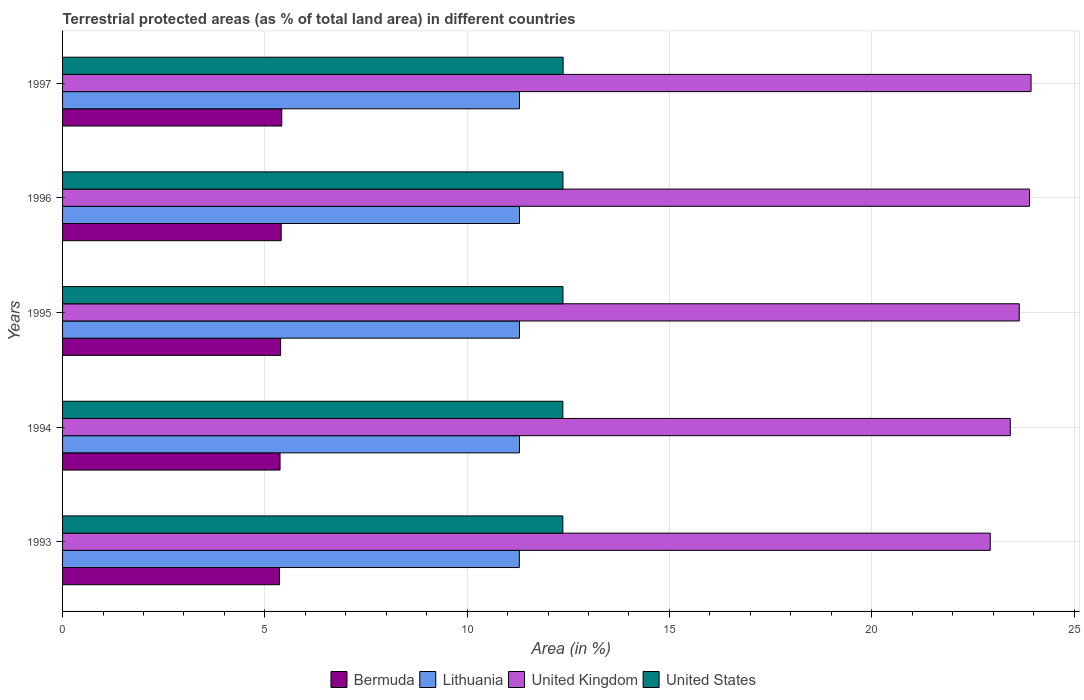Are the number of bars per tick equal to the number of legend labels?
Your answer should be compact. Yes. Are the number of bars on each tick of the Y-axis equal?
Your answer should be very brief. Yes. How many bars are there on the 2nd tick from the bottom?
Offer a very short reply. 4. What is the label of the 4th group of bars from the top?
Provide a short and direct response. 1994. In how many cases, is the number of bars for a given year not equal to the number of legend labels?
Your answer should be compact. 0. What is the percentage of terrestrial protected land in Bermuda in 1996?
Ensure brevity in your answer.  5.4. Across all years, what is the maximum percentage of terrestrial protected land in United States?
Make the answer very short. 12.37. Across all years, what is the minimum percentage of terrestrial protected land in United Kingdom?
Provide a succinct answer. 22.93. What is the total percentage of terrestrial protected land in Lithuania in the graph?
Your response must be concise. 56.47. What is the difference between the percentage of terrestrial protected land in Bermuda in 1994 and that in 1996?
Provide a short and direct response. -0.03. What is the difference between the percentage of terrestrial protected land in Lithuania in 1996 and the percentage of terrestrial protected land in Bermuda in 1997?
Your response must be concise. 5.88. What is the average percentage of terrestrial protected land in Lithuania per year?
Keep it short and to the point. 11.29. In the year 1993, what is the difference between the percentage of terrestrial protected land in Lithuania and percentage of terrestrial protected land in Bermuda?
Your answer should be very brief. 5.93. In how many years, is the percentage of terrestrial protected land in Bermuda greater than 11 %?
Make the answer very short. 0. What is the ratio of the percentage of terrestrial protected land in United States in 1993 to that in 1997?
Offer a terse response. 1. What is the difference between the highest and the second highest percentage of terrestrial protected land in United Kingdom?
Your answer should be compact. 0.04. What is the difference between the highest and the lowest percentage of terrestrial protected land in United Kingdom?
Your response must be concise. 1.01. Is it the case that in every year, the sum of the percentage of terrestrial protected land in Lithuania and percentage of terrestrial protected land in United States is greater than the sum of percentage of terrestrial protected land in Bermuda and percentage of terrestrial protected land in United Kingdom?
Your answer should be compact. Yes. What does the 3rd bar from the top in 1995 represents?
Keep it short and to the point. Lithuania. What does the 1st bar from the bottom in 1994 represents?
Your answer should be very brief. Bermuda. Is it the case that in every year, the sum of the percentage of terrestrial protected land in United States and percentage of terrestrial protected land in Bermuda is greater than the percentage of terrestrial protected land in Lithuania?
Your answer should be compact. Yes. What is the difference between two consecutive major ticks on the X-axis?
Offer a terse response. 5. Are the values on the major ticks of X-axis written in scientific E-notation?
Offer a very short reply. No. Does the graph contain any zero values?
Offer a terse response. No. Does the graph contain grids?
Provide a succinct answer. Yes. Where does the legend appear in the graph?
Offer a terse response. Bottom center. How many legend labels are there?
Give a very brief answer. 4. How are the legend labels stacked?
Your answer should be compact. Horizontal. What is the title of the graph?
Give a very brief answer. Terrestrial protected areas (as % of total land area) in different countries. What is the label or title of the X-axis?
Your answer should be compact. Area (in %). What is the label or title of the Y-axis?
Provide a succinct answer. Years. What is the Area (in %) of Bermuda in 1993?
Give a very brief answer. 5.36. What is the Area (in %) in Lithuania in 1993?
Keep it short and to the point. 11.29. What is the Area (in %) of United Kingdom in 1993?
Give a very brief answer. 22.93. What is the Area (in %) in United States in 1993?
Provide a succinct answer. 12.37. What is the Area (in %) of Bermuda in 1994?
Offer a terse response. 5.38. What is the Area (in %) of Lithuania in 1994?
Your response must be concise. 11.29. What is the Area (in %) of United Kingdom in 1994?
Your answer should be compact. 23.43. What is the Area (in %) of United States in 1994?
Offer a terse response. 12.37. What is the Area (in %) in Bermuda in 1995?
Provide a succinct answer. 5.39. What is the Area (in %) in Lithuania in 1995?
Offer a very short reply. 11.29. What is the Area (in %) in United Kingdom in 1995?
Make the answer very short. 23.65. What is the Area (in %) of United States in 1995?
Keep it short and to the point. 12.37. What is the Area (in %) of Bermuda in 1996?
Make the answer very short. 5.4. What is the Area (in %) of Lithuania in 1996?
Your answer should be very brief. 11.29. What is the Area (in %) of United Kingdom in 1996?
Your answer should be very brief. 23.9. What is the Area (in %) of United States in 1996?
Make the answer very short. 12.37. What is the Area (in %) in Bermuda in 1997?
Provide a succinct answer. 5.42. What is the Area (in %) of Lithuania in 1997?
Your response must be concise. 11.29. What is the Area (in %) of United Kingdom in 1997?
Keep it short and to the point. 23.94. What is the Area (in %) of United States in 1997?
Your response must be concise. 12.37. Across all years, what is the maximum Area (in %) of Bermuda?
Offer a terse response. 5.42. Across all years, what is the maximum Area (in %) of Lithuania?
Provide a short and direct response. 11.29. Across all years, what is the maximum Area (in %) of United Kingdom?
Your answer should be compact. 23.94. Across all years, what is the maximum Area (in %) of United States?
Provide a short and direct response. 12.37. Across all years, what is the minimum Area (in %) in Bermuda?
Ensure brevity in your answer.  5.36. Across all years, what is the minimum Area (in %) in Lithuania?
Provide a succinct answer. 11.29. Across all years, what is the minimum Area (in %) of United Kingdom?
Provide a succinct answer. 22.93. Across all years, what is the minimum Area (in %) of United States?
Keep it short and to the point. 12.37. What is the total Area (in %) of Bermuda in the graph?
Give a very brief answer. 26.95. What is the total Area (in %) of Lithuania in the graph?
Your answer should be compact. 56.47. What is the total Area (in %) of United Kingdom in the graph?
Your answer should be very brief. 117.84. What is the total Area (in %) of United States in the graph?
Your response must be concise. 61.84. What is the difference between the Area (in %) in Bermuda in 1993 and that in 1994?
Give a very brief answer. -0.01. What is the difference between the Area (in %) in Lithuania in 1993 and that in 1994?
Provide a succinct answer. -0. What is the difference between the Area (in %) of United Kingdom in 1993 and that in 1994?
Provide a succinct answer. -0.5. What is the difference between the Area (in %) in United States in 1993 and that in 1994?
Keep it short and to the point. -0. What is the difference between the Area (in %) of Bermuda in 1993 and that in 1995?
Provide a succinct answer. -0.03. What is the difference between the Area (in %) in Lithuania in 1993 and that in 1995?
Your answer should be very brief. -0. What is the difference between the Area (in %) in United Kingdom in 1993 and that in 1995?
Offer a very short reply. -0.72. What is the difference between the Area (in %) of United States in 1993 and that in 1995?
Offer a terse response. -0. What is the difference between the Area (in %) of Bermuda in 1993 and that in 1996?
Make the answer very short. -0.04. What is the difference between the Area (in %) of Lithuania in 1993 and that in 1996?
Offer a very short reply. -0. What is the difference between the Area (in %) in United Kingdom in 1993 and that in 1996?
Make the answer very short. -0.97. What is the difference between the Area (in %) of United States in 1993 and that in 1996?
Your answer should be compact. -0. What is the difference between the Area (in %) of Bermuda in 1993 and that in 1997?
Ensure brevity in your answer.  -0.06. What is the difference between the Area (in %) in Lithuania in 1993 and that in 1997?
Provide a succinct answer. -0. What is the difference between the Area (in %) of United Kingdom in 1993 and that in 1997?
Make the answer very short. -1.01. What is the difference between the Area (in %) in United States in 1993 and that in 1997?
Your answer should be compact. -0.01. What is the difference between the Area (in %) of Bermuda in 1994 and that in 1995?
Provide a short and direct response. -0.01. What is the difference between the Area (in %) in United Kingdom in 1994 and that in 1995?
Offer a very short reply. -0.22. What is the difference between the Area (in %) in United States in 1994 and that in 1995?
Provide a short and direct response. -0. What is the difference between the Area (in %) of Bermuda in 1994 and that in 1996?
Keep it short and to the point. -0.03. What is the difference between the Area (in %) in Lithuania in 1994 and that in 1996?
Keep it short and to the point. 0. What is the difference between the Area (in %) of United Kingdom in 1994 and that in 1996?
Give a very brief answer. -0.48. What is the difference between the Area (in %) in United States in 1994 and that in 1996?
Your answer should be very brief. -0. What is the difference between the Area (in %) in Bermuda in 1994 and that in 1997?
Provide a short and direct response. -0.04. What is the difference between the Area (in %) of Lithuania in 1994 and that in 1997?
Ensure brevity in your answer.  0. What is the difference between the Area (in %) in United Kingdom in 1994 and that in 1997?
Your answer should be very brief. -0.51. What is the difference between the Area (in %) in United States in 1994 and that in 1997?
Keep it short and to the point. -0.01. What is the difference between the Area (in %) of Bermuda in 1995 and that in 1996?
Offer a very short reply. -0.01. What is the difference between the Area (in %) in United Kingdom in 1995 and that in 1996?
Provide a succinct answer. -0.26. What is the difference between the Area (in %) in Bermuda in 1995 and that in 1997?
Your answer should be compact. -0.03. What is the difference between the Area (in %) of United Kingdom in 1995 and that in 1997?
Give a very brief answer. -0.29. What is the difference between the Area (in %) of United States in 1995 and that in 1997?
Your answer should be compact. -0. What is the difference between the Area (in %) in Bermuda in 1996 and that in 1997?
Make the answer very short. -0.01. What is the difference between the Area (in %) of United Kingdom in 1996 and that in 1997?
Keep it short and to the point. -0.04. What is the difference between the Area (in %) in United States in 1996 and that in 1997?
Your answer should be compact. -0. What is the difference between the Area (in %) in Bermuda in 1993 and the Area (in %) in Lithuania in 1994?
Offer a terse response. -5.93. What is the difference between the Area (in %) in Bermuda in 1993 and the Area (in %) in United Kingdom in 1994?
Keep it short and to the point. -18.06. What is the difference between the Area (in %) in Bermuda in 1993 and the Area (in %) in United States in 1994?
Provide a succinct answer. -7. What is the difference between the Area (in %) in Lithuania in 1993 and the Area (in %) in United Kingdom in 1994?
Make the answer very short. -12.13. What is the difference between the Area (in %) of Lithuania in 1993 and the Area (in %) of United States in 1994?
Offer a very short reply. -1.08. What is the difference between the Area (in %) in United Kingdom in 1993 and the Area (in %) in United States in 1994?
Provide a short and direct response. 10.56. What is the difference between the Area (in %) of Bermuda in 1993 and the Area (in %) of Lithuania in 1995?
Your answer should be compact. -5.93. What is the difference between the Area (in %) in Bermuda in 1993 and the Area (in %) in United Kingdom in 1995?
Ensure brevity in your answer.  -18.28. What is the difference between the Area (in %) of Bermuda in 1993 and the Area (in %) of United States in 1995?
Your response must be concise. -7.01. What is the difference between the Area (in %) in Lithuania in 1993 and the Area (in %) in United Kingdom in 1995?
Ensure brevity in your answer.  -12.36. What is the difference between the Area (in %) in Lithuania in 1993 and the Area (in %) in United States in 1995?
Ensure brevity in your answer.  -1.08. What is the difference between the Area (in %) in United Kingdom in 1993 and the Area (in %) in United States in 1995?
Make the answer very short. 10.56. What is the difference between the Area (in %) in Bermuda in 1993 and the Area (in %) in Lithuania in 1996?
Make the answer very short. -5.93. What is the difference between the Area (in %) in Bermuda in 1993 and the Area (in %) in United Kingdom in 1996?
Your answer should be very brief. -18.54. What is the difference between the Area (in %) in Bermuda in 1993 and the Area (in %) in United States in 1996?
Make the answer very short. -7.01. What is the difference between the Area (in %) in Lithuania in 1993 and the Area (in %) in United Kingdom in 1996?
Ensure brevity in your answer.  -12.61. What is the difference between the Area (in %) in Lithuania in 1993 and the Area (in %) in United States in 1996?
Give a very brief answer. -1.08. What is the difference between the Area (in %) of United Kingdom in 1993 and the Area (in %) of United States in 1996?
Provide a short and direct response. 10.56. What is the difference between the Area (in %) of Bermuda in 1993 and the Area (in %) of Lithuania in 1997?
Keep it short and to the point. -5.93. What is the difference between the Area (in %) of Bermuda in 1993 and the Area (in %) of United Kingdom in 1997?
Make the answer very short. -18.58. What is the difference between the Area (in %) in Bermuda in 1993 and the Area (in %) in United States in 1997?
Offer a terse response. -7.01. What is the difference between the Area (in %) of Lithuania in 1993 and the Area (in %) of United Kingdom in 1997?
Offer a terse response. -12.65. What is the difference between the Area (in %) in Lithuania in 1993 and the Area (in %) in United States in 1997?
Give a very brief answer. -1.08. What is the difference between the Area (in %) of United Kingdom in 1993 and the Area (in %) of United States in 1997?
Ensure brevity in your answer.  10.56. What is the difference between the Area (in %) in Bermuda in 1994 and the Area (in %) in Lithuania in 1995?
Your answer should be very brief. -5.92. What is the difference between the Area (in %) of Bermuda in 1994 and the Area (in %) of United Kingdom in 1995?
Offer a terse response. -18.27. What is the difference between the Area (in %) of Bermuda in 1994 and the Area (in %) of United States in 1995?
Provide a short and direct response. -6.99. What is the difference between the Area (in %) of Lithuania in 1994 and the Area (in %) of United Kingdom in 1995?
Make the answer very short. -12.35. What is the difference between the Area (in %) in Lithuania in 1994 and the Area (in %) in United States in 1995?
Give a very brief answer. -1.07. What is the difference between the Area (in %) of United Kingdom in 1994 and the Area (in %) of United States in 1995?
Give a very brief answer. 11.06. What is the difference between the Area (in %) of Bermuda in 1994 and the Area (in %) of Lithuania in 1996?
Make the answer very short. -5.92. What is the difference between the Area (in %) in Bermuda in 1994 and the Area (in %) in United Kingdom in 1996?
Make the answer very short. -18.53. What is the difference between the Area (in %) of Bermuda in 1994 and the Area (in %) of United States in 1996?
Your response must be concise. -6.99. What is the difference between the Area (in %) in Lithuania in 1994 and the Area (in %) in United Kingdom in 1996?
Ensure brevity in your answer.  -12.61. What is the difference between the Area (in %) of Lithuania in 1994 and the Area (in %) of United States in 1996?
Offer a very short reply. -1.07. What is the difference between the Area (in %) in United Kingdom in 1994 and the Area (in %) in United States in 1996?
Ensure brevity in your answer.  11.06. What is the difference between the Area (in %) in Bermuda in 1994 and the Area (in %) in Lithuania in 1997?
Your answer should be very brief. -5.92. What is the difference between the Area (in %) in Bermuda in 1994 and the Area (in %) in United Kingdom in 1997?
Your answer should be compact. -18.56. What is the difference between the Area (in %) in Bermuda in 1994 and the Area (in %) in United States in 1997?
Give a very brief answer. -7. What is the difference between the Area (in %) of Lithuania in 1994 and the Area (in %) of United Kingdom in 1997?
Keep it short and to the point. -12.64. What is the difference between the Area (in %) of Lithuania in 1994 and the Area (in %) of United States in 1997?
Provide a short and direct response. -1.08. What is the difference between the Area (in %) of United Kingdom in 1994 and the Area (in %) of United States in 1997?
Keep it short and to the point. 11.05. What is the difference between the Area (in %) of Bermuda in 1995 and the Area (in %) of Lithuania in 1996?
Offer a very short reply. -5.9. What is the difference between the Area (in %) of Bermuda in 1995 and the Area (in %) of United Kingdom in 1996?
Your answer should be compact. -18.51. What is the difference between the Area (in %) in Bermuda in 1995 and the Area (in %) in United States in 1996?
Keep it short and to the point. -6.98. What is the difference between the Area (in %) of Lithuania in 1995 and the Area (in %) of United Kingdom in 1996?
Offer a very short reply. -12.61. What is the difference between the Area (in %) of Lithuania in 1995 and the Area (in %) of United States in 1996?
Your answer should be compact. -1.07. What is the difference between the Area (in %) in United Kingdom in 1995 and the Area (in %) in United States in 1996?
Make the answer very short. 11.28. What is the difference between the Area (in %) of Bermuda in 1995 and the Area (in %) of Lithuania in 1997?
Your response must be concise. -5.9. What is the difference between the Area (in %) in Bermuda in 1995 and the Area (in %) in United Kingdom in 1997?
Provide a short and direct response. -18.55. What is the difference between the Area (in %) of Bermuda in 1995 and the Area (in %) of United States in 1997?
Your answer should be very brief. -6.98. What is the difference between the Area (in %) in Lithuania in 1995 and the Area (in %) in United Kingdom in 1997?
Your answer should be very brief. -12.64. What is the difference between the Area (in %) of Lithuania in 1995 and the Area (in %) of United States in 1997?
Your answer should be compact. -1.08. What is the difference between the Area (in %) in United Kingdom in 1995 and the Area (in %) in United States in 1997?
Ensure brevity in your answer.  11.27. What is the difference between the Area (in %) in Bermuda in 1996 and the Area (in %) in Lithuania in 1997?
Your response must be concise. -5.89. What is the difference between the Area (in %) in Bermuda in 1996 and the Area (in %) in United Kingdom in 1997?
Offer a very short reply. -18.54. What is the difference between the Area (in %) of Bermuda in 1996 and the Area (in %) of United States in 1997?
Give a very brief answer. -6.97. What is the difference between the Area (in %) in Lithuania in 1996 and the Area (in %) in United Kingdom in 1997?
Offer a terse response. -12.64. What is the difference between the Area (in %) of Lithuania in 1996 and the Area (in %) of United States in 1997?
Provide a succinct answer. -1.08. What is the difference between the Area (in %) of United Kingdom in 1996 and the Area (in %) of United States in 1997?
Your answer should be very brief. 11.53. What is the average Area (in %) of Bermuda per year?
Your answer should be very brief. 5.39. What is the average Area (in %) of Lithuania per year?
Your answer should be very brief. 11.29. What is the average Area (in %) in United Kingdom per year?
Your response must be concise. 23.57. What is the average Area (in %) in United States per year?
Your answer should be very brief. 12.37. In the year 1993, what is the difference between the Area (in %) in Bermuda and Area (in %) in Lithuania?
Your answer should be very brief. -5.93. In the year 1993, what is the difference between the Area (in %) in Bermuda and Area (in %) in United Kingdom?
Make the answer very short. -17.57. In the year 1993, what is the difference between the Area (in %) in Bermuda and Area (in %) in United States?
Keep it short and to the point. -7. In the year 1993, what is the difference between the Area (in %) in Lithuania and Area (in %) in United Kingdom?
Provide a short and direct response. -11.64. In the year 1993, what is the difference between the Area (in %) in Lithuania and Area (in %) in United States?
Provide a succinct answer. -1.07. In the year 1993, what is the difference between the Area (in %) of United Kingdom and Area (in %) of United States?
Keep it short and to the point. 10.56. In the year 1994, what is the difference between the Area (in %) of Bermuda and Area (in %) of Lithuania?
Provide a short and direct response. -5.92. In the year 1994, what is the difference between the Area (in %) in Bermuda and Area (in %) in United Kingdom?
Give a very brief answer. -18.05. In the year 1994, what is the difference between the Area (in %) in Bermuda and Area (in %) in United States?
Give a very brief answer. -6.99. In the year 1994, what is the difference between the Area (in %) in Lithuania and Area (in %) in United Kingdom?
Provide a succinct answer. -12.13. In the year 1994, what is the difference between the Area (in %) of Lithuania and Area (in %) of United States?
Offer a terse response. -1.07. In the year 1994, what is the difference between the Area (in %) in United Kingdom and Area (in %) in United States?
Make the answer very short. 11.06. In the year 1995, what is the difference between the Area (in %) in Bermuda and Area (in %) in Lithuania?
Your response must be concise. -5.9. In the year 1995, what is the difference between the Area (in %) of Bermuda and Area (in %) of United Kingdom?
Provide a short and direct response. -18.26. In the year 1995, what is the difference between the Area (in %) in Bermuda and Area (in %) in United States?
Offer a very short reply. -6.98. In the year 1995, what is the difference between the Area (in %) in Lithuania and Area (in %) in United Kingdom?
Provide a short and direct response. -12.35. In the year 1995, what is the difference between the Area (in %) in Lithuania and Area (in %) in United States?
Ensure brevity in your answer.  -1.07. In the year 1995, what is the difference between the Area (in %) of United Kingdom and Area (in %) of United States?
Offer a terse response. 11.28. In the year 1996, what is the difference between the Area (in %) in Bermuda and Area (in %) in Lithuania?
Keep it short and to the point. -5.89. In the year 1996, what is the difference between the Area (in %) of Bermuda and Area (in %) of United Kingdom?
Ensure brevity in your answer.  -18.5. In the year 1996, what is the difference between the Area (in %) in Bermuda and Area (in %) in United States?
Provide a short and direct response. -6.97. In the year 1996, what is the difference between the Area (in %) of Lithuania and Area (in %) of United Kingdom?
Provide a succinct answer. -12.61. In the year 1996, what is the difference between the Area (in %) of Lithuania and Area (in %) of United States?
Ensure brevity in your answer.  -1.07. In the year 1996, what is the difference between the Area (in %) in United Kingdom and Area (in %) in United States?
Your answer should be very brief. 11.53. In the year 1997, what is the difference between the Area (in %) in Bermuda and Area (in %) in Lithuania?
Make the answer very short. -5.88. In the year 1997, what is the difference between the Area (in %) in Bermuda and Area (in %) in United Kingdom?
Make the answer very short. -18.52. In the year 1997, what is the difference between the Area (in %) in Bermuda and Area (in %) in United States?
Offer a very short reply. -6.95. In the year 1997, what is the difference between the Area (in %) of Lithuania and Area (in %) of United Kingdom?
Your answer should be very brief. -12.64. In the year 1997, what is the difference between the Area (in %) of Lithuania and Area (in %) of United States?
Keep it short and to the point. -1.08. In the year 1997, what is the difference between the Area (in %) of United Kingdom and Area (in %) of United States?
Provide a short and direct response. 11.57. What is the ratio of the Area (in %) of United Kingdom in 1993 to that in 1994?
Your response must be concise. 0.98. What is the ratio of the Area (in %) in Bermuda in 1993 to that in 1995?
Provide a succinct answer. 0.99. What is the ratio of the Area (in %) of Lithuania in 1993 to that in 1995?
Offer a terse response. 1. What is the ratio of the Area (in %) of United Kingdom in 1993 to that in 1995?
Your answer should be very brief. 0.97. What is the ratio of the Area (in %) in United States in 1993 to that in 1995?
Provide a short and direct response. 1. What is the ratio of the Area (in %) of Lithuania in 1993 to that in 1996?
Offer a very short reply. 1. What is the ratio of the Area (in %) of United Kingdom in 1993 to that in 1996?
Your answer should be very brief. 0.96. What is the ratio of the Area (in %) in Bermuda in 1993 to that in 1997?
Give a very brief answer. 0.99. What is the ratio of the Area (in %) of United Kingdom in 1993 to that in 1997?
Offer a very short reply. 0.96. What is the ratio of the Area (in %) in United States in 1993 to that in 1997?
Give a very brief answer. 1. What is the ratio of the Area (in %) of Lithuania in 1994 to that in 1995?
Ensure brevity in your answer.  1. What is the ratio of the Area (in %) of United Kingdom in 1994 to that in 1995?
Provide a succinct answer. 0.99. What is the ratio of the Area (in %) in United Kingdom in 1994 to that in 1996?
Offer a very short reply. 0.98. What is the ratio of the Area (in %) in United States in 1994 to that in 1996?
Your answer should be compact. 1. What is the ratio of the Area (in %) in Bermuda in 1994 to that in 1997?
Your response must be concise. 0.99. What is the ratio of the Area (in %) of Lithuania in 1994 to that in 1997?
Provide a short and direct response. 1. What is the ratio of the Area (in %) in United Kingdom in 1994 to that in 1997?
Your answer should be compact. 0.98. What is the ratio of the Area (in %) of United States in 1994 to that in 1997?
Your answer should be very brief. 1. What is the ratio of the Area (in %) in United Kingdom in 1995 to that in 1996?
Ensure brevity in your answer.  0.99. What is the ratio of the Area (in %) in United States in 1995 to that in 1996?
Your answer should be compact. 1. What is the ratio of the Area (in %) of Lithuania in 1995 to that in 1997?
Offer a terse response. 1. What is the ratio of the Area (in %) in United States in 1995 to that in 1997?
Ensure brevity in your answer.  1. What is the ratio of the Area (in %) of Lithuania in 1996 to that in 1997?
Offer a terse response. 1. What is the ratio of the Area (in %) of United Kingdom in 1996 to that in 1997?
Offer a terse response. 1. What is the difference between the highest and the second highest Area (in %) in Bermuda?
Your answer should be very brief. 0.01. What is the difference between the highest and the second highest Area (in %) of Lithuania?
Offer a terse response. 0. What is the difference between the highest and the second highest Area (in %) of United Kingdom?
Your response must be concise. 0.04. What is the difference between the highest and the second highest Area (in %) in United States?
Keep it short and to the point. 0. What is the difference between the highest and the lowest Area (in %) in Bermuda?
Offer a terse response. 0.06. What is the difference between the highest and the lowest Area (in %) of Lithuania?
Your answer should be compact. 0. What is the difference between the highest and the lowest Area (in %) in United Kingdom?
Provide a short and direct response. 1.01. What is the difference between the highest and the lowest Area (in %) of United States?
Keep it short and to the point. 0.01. 